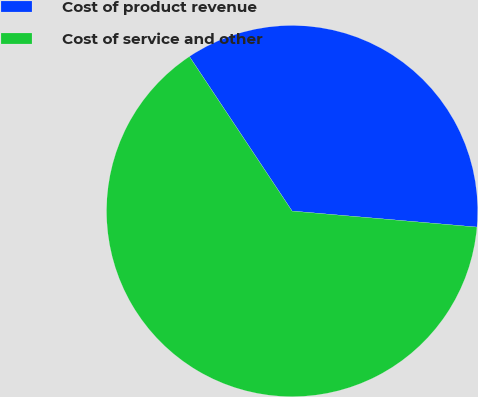Convert chart. <chart><loc_0><loc_0><loc_500><loc_500><pie_chart><fcel>Cost of product revenue<fcel>Cost of service and other<nl><fcel>35.71%<fcel>64.29%<nl></chart> 